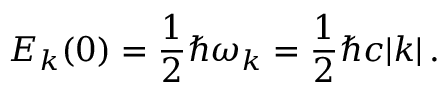Convert formula to latex. <formula><loc_0><loc_0><loc_500><loc_500>E _ { k } ( 0 ) = \frac { 1 } { 2 } \hbar { \omega } _ { k } = \frac { 1 } { 2 } \hbar { c } | k | \, .</formula> 